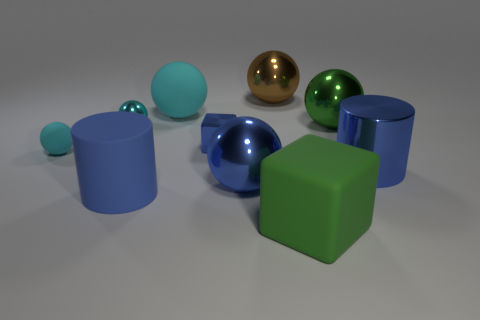Subtract all gray cylinders. How many cyan balls are left? 3 Subtract all blue balls. How many balls are left? 5 Subtract all green metal balls. How many balls are left? 5 Subtract 2 balls. How many balls are left? 4 Subtract all blue spheres. Subtract all gray blocks. How many spheres are left? 5 Subtract all spheres. How many objects are left? 4 Subtract 0 red spheres. How many objects are left? 10 Subtract all yellow matte objects. Subtract all big brown things. How many objects are left? 9 Add 8 big green objects. How many big green objects are left? 10 Add 3 cylinders. How many cylinders exist? 5 